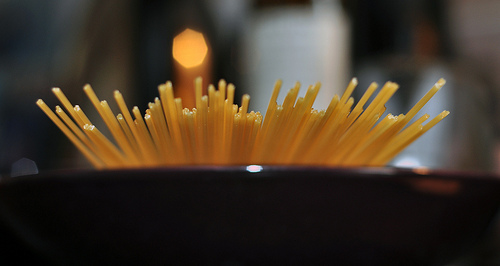<image>
Is the pasta next to the pan? No. The pasta is not positioned next to the pan. They are located in different areas of the scene. Is there a light in front of the food? No. The light is not in front of the food. The spatial positioning shows a different relationship between these objects. 